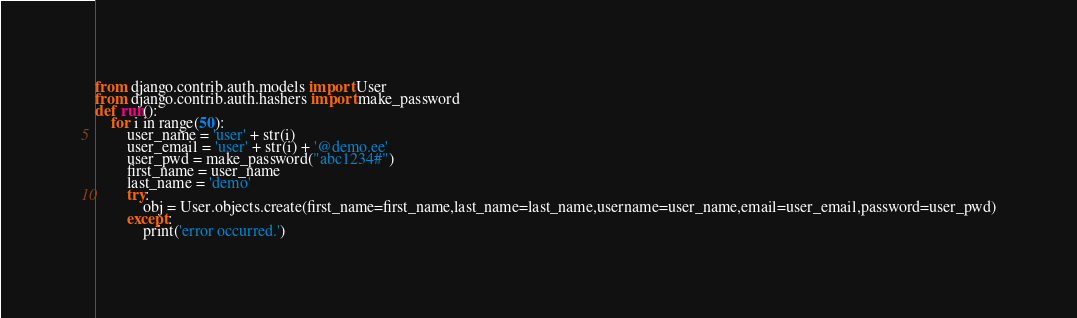<code> <loc_0><loc_0><loc_500><loc_500><_Python_>from django.contrib.auth.models import User
from django.contrib.auth.hashers import make_password
def run():
    for i in range(50):
        user_name = 'user' + str(i)
        user_email = 'user' + str(i) + '@demo.ee'
        user_pwd = make_password("abc1234#")
        first_name = user_name
        last_name = 'demo'
        try:
            obj = User.objects.create(first_name=first_name,last_name=last_name,username=user_name,email=user_email,password=user_pwd)
        except:
            print('error occurred.')
</code> 